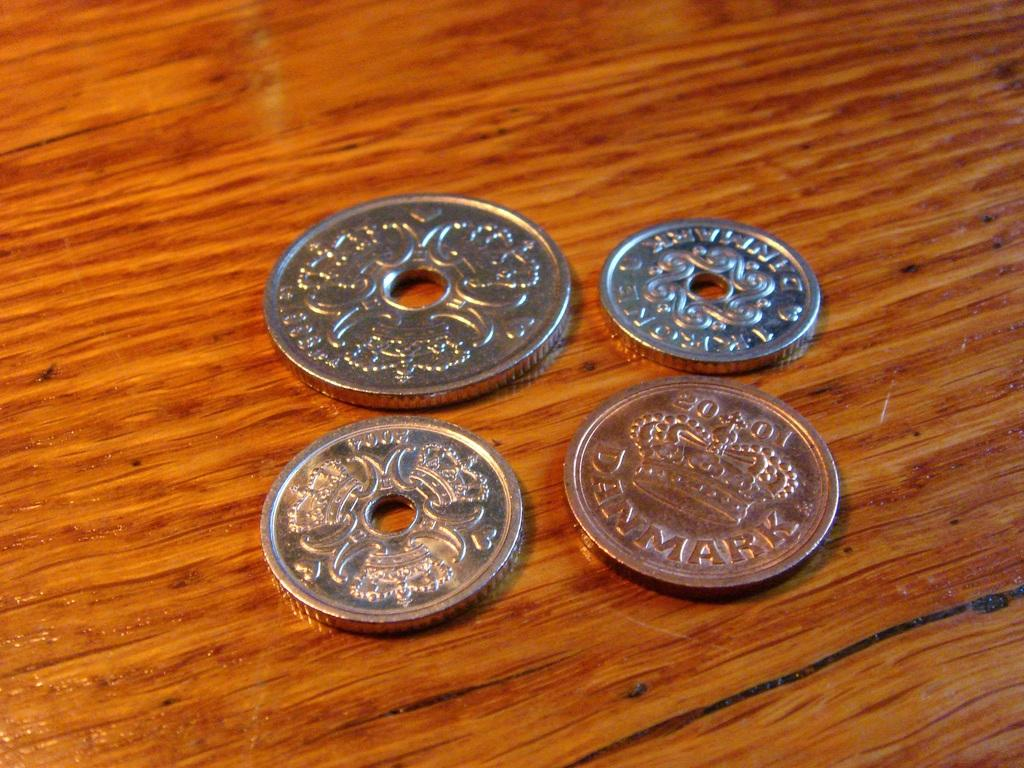Provide a one-sentence caption for the provided image. Four coins from Denmark sitting on a wood surface. 